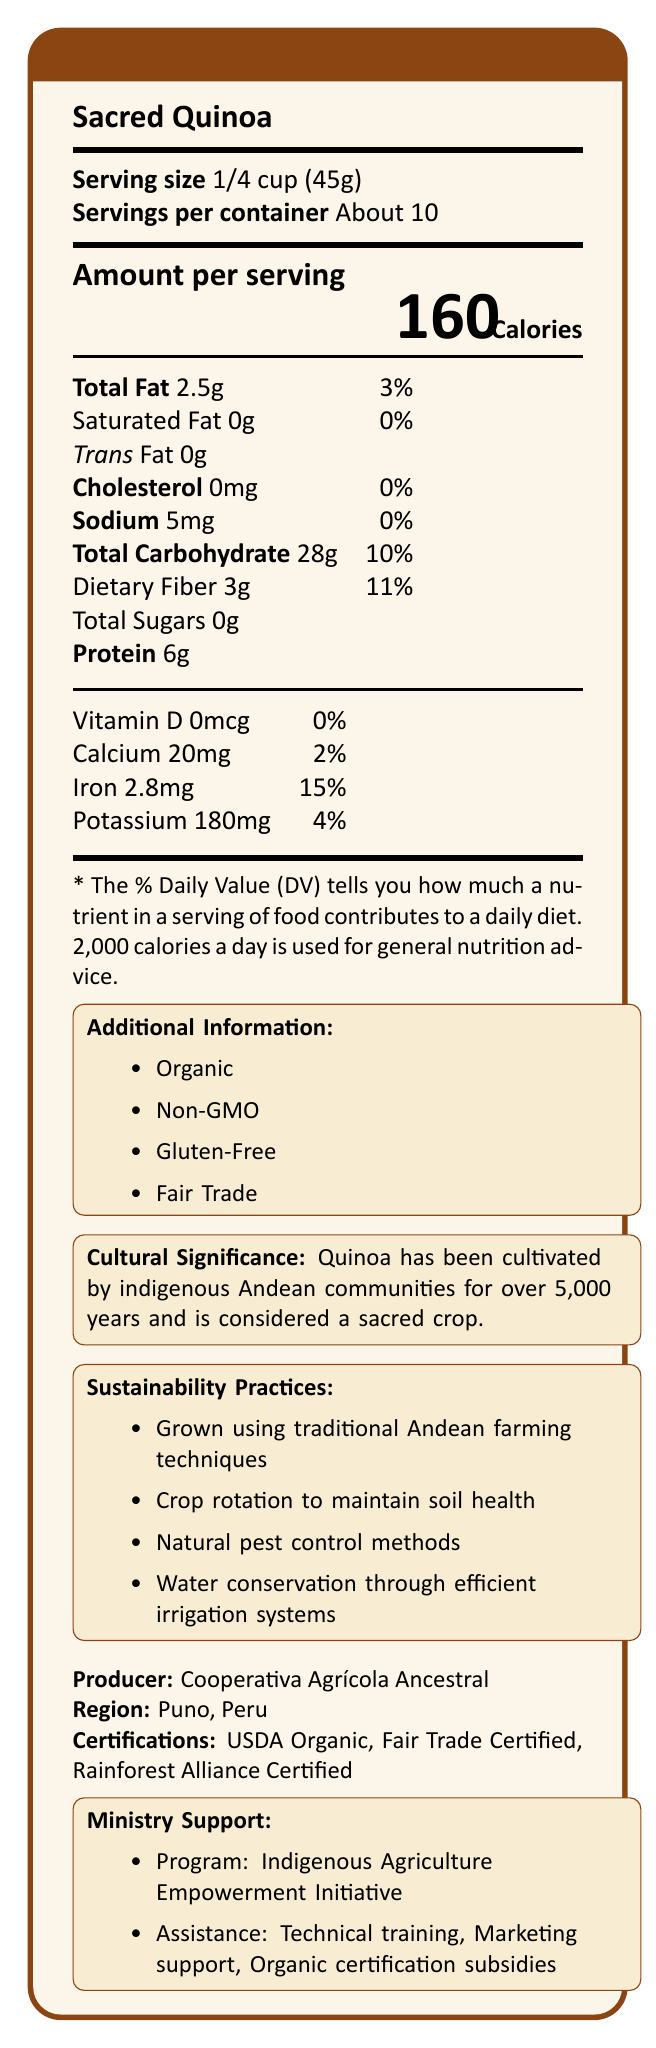what is the serving size? The document states that the serving size is 1/4 cup (45g).
Answer: 1/4 cup (45g) how many servings are in a container? The document indicates that there are about 10 servings per container.
Answer: About 10 how many calories are in one serving? According to the document, there are 160 calories in one serving.
Answer: 160 what is the amount of dietary fiber per serving? The nutritional information mentions that each serving contains 3g of dietary fiber.
Answer: 3g which certifications does the product have? The document lists the certifications as USDA Organic, Fair Trade Certified, and Rainforest Alliance Certified.
Answer: USDA Organic, Fair Trade Certified, Rainforest Alliance Certified what is the total fat content in one serving? The total fat content per serving is 2.5g as mentioned in the document.
Answer: 2.5g how much calcium does one serving provide? The document states that one serving provides 20mg of calcium, which is 2% of the Daily Value.
Answer: 20mg (2% Daily Value) how much iron is in one serving of Sacred Quinoa? According to the nutritional information, one serving of Sacred Quinoa contains 2.8mg of iron, which is 15% of the Daily Value.
Answer: 2.8mg (15% Daily Value) what is the sodium content per serving? The document shows that the sodium content per serving is 5mg.
Answer: 5mg which of the following best describes the cultural significance of Quinoa? A. Popular in modern diets B. High in protein C. Cultivated by indigenous Andean communities for over 5,000 years and considered sacred D. Not widely known outside South America The document states that Quinoa has been cultivated by indigenous Andean communities for over 5,000 years and is considered a sacred crop.
Answer: C which sustainability practice is NOT mentioned in the document? A. Grown using traditional Andean farming techniques B. Use of biodegradable packaging C. Crop rotation to maintain soil health D. Natural pest control methods The document does not mention the use of biodegradable packaging as a sustainability practice.
Answer: B is the product gluten-free? The document lists "Gluten-Free" under additional information about the product.
Answer: Yes what is the main purpose of the Ministry Support Program mentioned in the document? The Ministry Support Program aims to empower indigenous communities by providing technical training on organic farming practices, marketing support for international markets, and subsidies for organic certification.
Answer: To empower indigenous communities through technical training, marketing support, and subsidies for organic certification where is the producer of Sacred Quinoa located? The document states that the producer, Cooperativa Agrícola Ancestral, is located in Puno, Peru.
Answer: Puno, Peru how much protein does one serving of Sacred Quinoa contain? The nutritional information indicates that one serving of Sacred Quinoa contains 6g of protein.
Answer: 6g what program supports Sacred Quinoa's sustainability practices? The document does not specify which program supports Sacred Quinoa's sustainability practices, only that it follows practices like traditional Andean farming, crop rotation, natural pest control, and efficient irrigation.
Answer: Cannot be determined describe the main idea of the document. The document details the nutritional content, sustainability, cultural background, certifications, and ministry support associated with Sacred Quinoa, a crop with deep roots in Andean culture and sustainable farming practices.
Answer: The document provides nutritional information about Sacred Quinoa, emphasizing its organic and non-GMO attributes, sustainability practices, cultural significance, and certifications. It also highlights ministry support for sustainable agriculture initiatives among indigenous communities. 